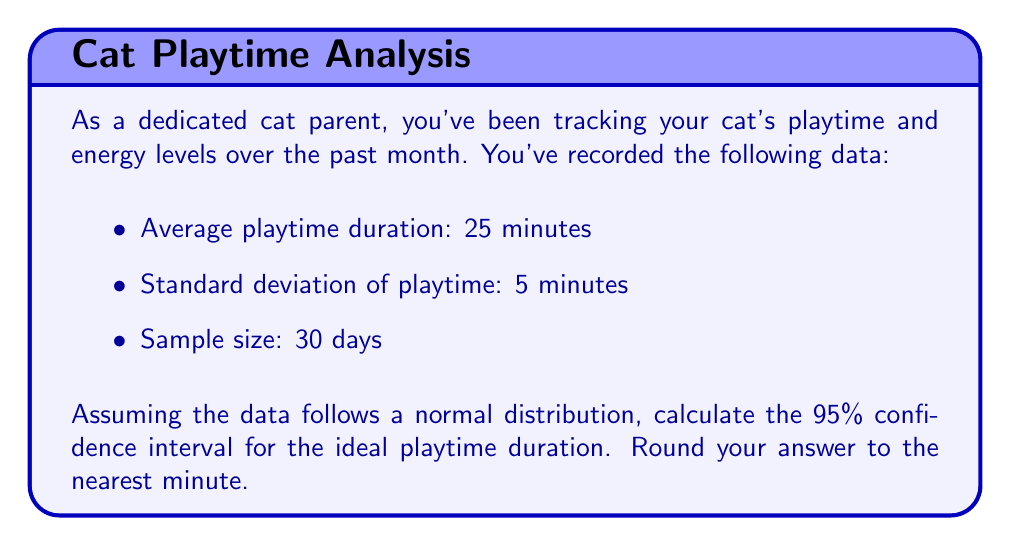Solve this math problem. To calculate the 95% confidence interval for the ideal playtime duration, we'll use the formula:

$$ \text{CI} = \bar{x} \pm t_{\alpha/2} \cdot \frac{s}{\sqrt{n}} $$

Where:
- $\bar{x}$ is the sample mean (average playtime duration)
- $t_{\alpha/2}$ is the t-value for a 95% confidence interval with n-1 degrees of freedom
- $s$ is the sample standard deviation
- $n$ is the sample size

Step 1: Identify the known values
- $\bar{x} = 25$ minutes
- $s = 5$ minutes
- $n = 30$ days
- Confidence level = 95% (α = 0.05)
- Degrees of freedom (df) = n - 1 = 29

Step 2: Find the t-value
For a 95% confidence interval with 29 degrees of freedom, the t-value is approximately 2.045 (from a t-distribution table or calculator).

Step 3: Calculate the margin of error
$$ \text{Margin of Error} = t_{\alpha/2} \cdot \frac{s}{\sqrt{n}} = 2.045 \cdot \frac{5}{\sqrt{30}} \approx 1.87 $$

Step 4: Calculate the confidence interval
$$ \text{CI} = 25 \pm 1.87 $$
$$ \text{Lower bound} = 25 - 1.87 = 23.13 $$
$$ \text{Upper bound} = 25 + 1.87 = 26.87 $$

Step 5: Round to the nearest minute
Lower bound: 23 minutes
Upper bound: 27 minutes
Answer: 23 to 27 minutes 